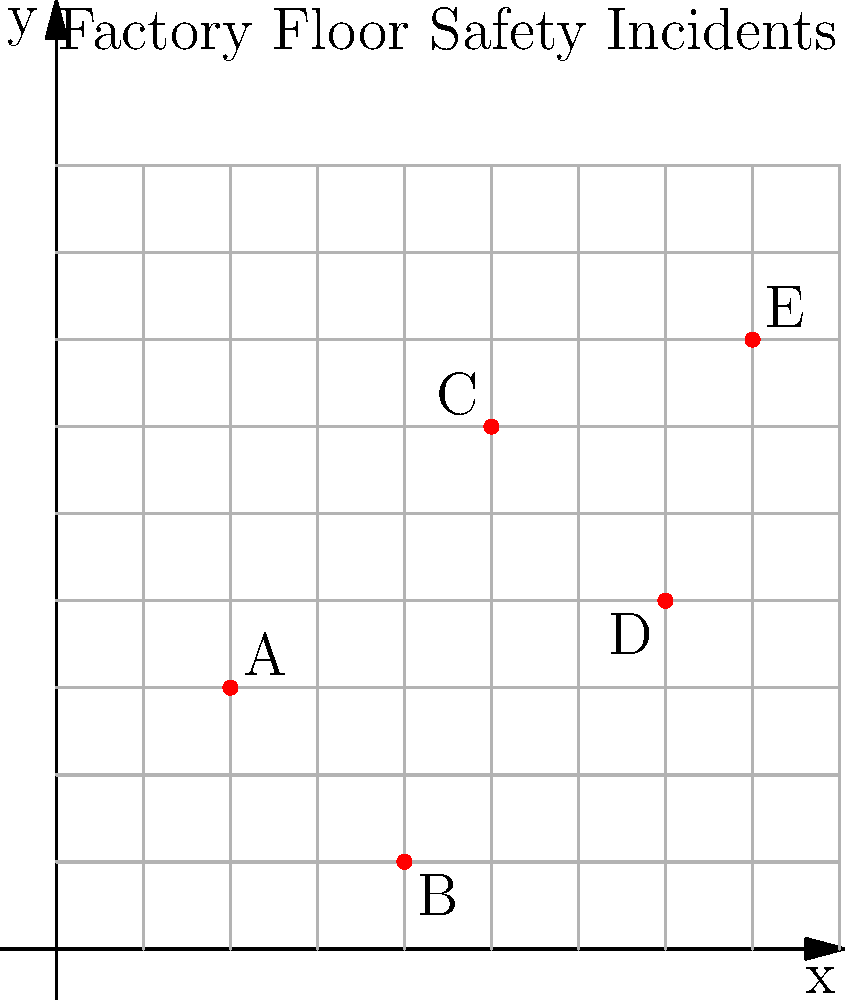As the HR manager responsible for workplace safety, you're analyzing a map of safety incidents on the factory floor. The incidents are plotted on a coordinate grid, where each unit represents 5 meters. If you need to calculate the total area of the factory floor that requires immediate safety inspection (defined as the rectangular area that encompasses all incident points), what is this area in square meters? To solve this problem, we need to follow these steps:

1. Identify the extreme points:
   - Leftmost point: A (2, 3)
   - Rightmost point: E (8, 7)
   - Lowest point: B (4, 1)
   - Highest point: E (8, 7)

2. Calculate the width of the rectangle:
   - Width = x-coordinate of rightmost point - x-coordinate of leftmost point
   - Width = 8 - 2 = 6 units

3. Calculate the height of the rectangle:
   - Height = y-coordinate of highest point - y-coordinate of lowest point
   - Height = 7 - 1 = 6 units

4. Calculate the area in grid units:
   - Area = Width × Height
   - Area = 6 × 6 = 36 square units

5. Convert the area to square meters:
   - Each unit represents 5 meters
   - Area in square meters = 36 × 5² = 36 × 25 = 900 square meters

Therefore, the total area of the factory floor that requires immediate safety inspection is 900 square meters.
Answer: 900 square meters 